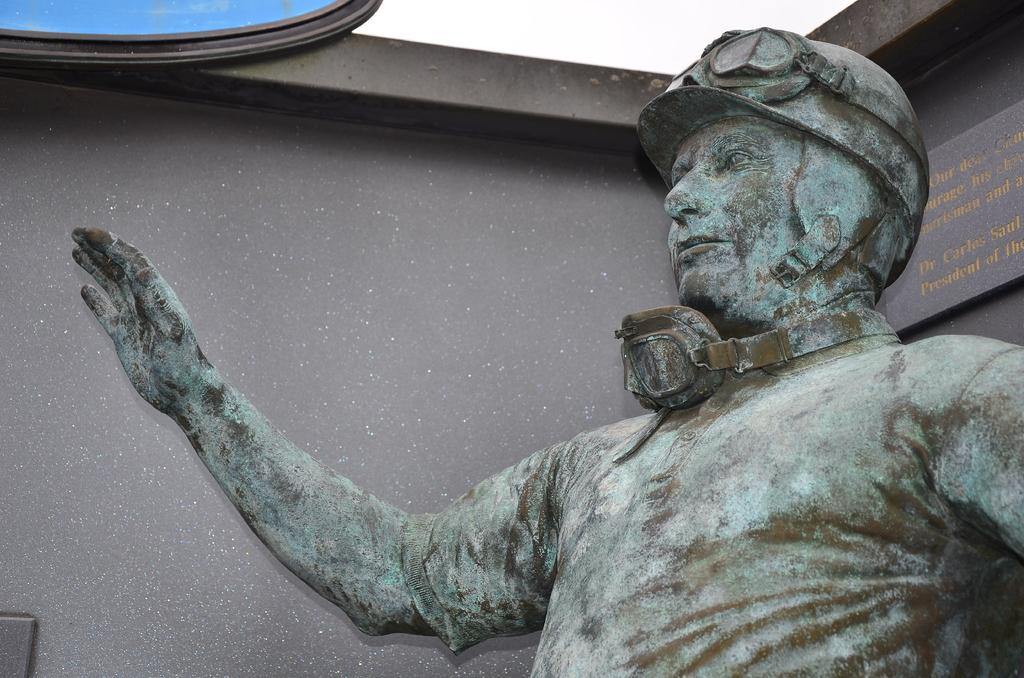What is the main subject of the image? There is a sculpture in the image. What time of day is depicted in the image, and how does the sculpture contribute to the trouble in the hour? There is no information provided about the time of day or any trouble in the image. The image only features a sculpture. 